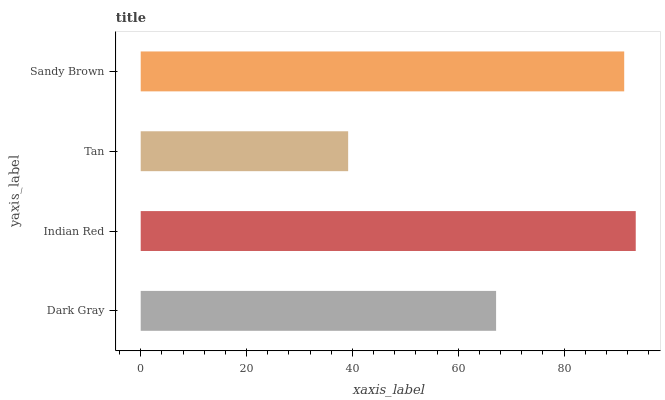Is Tan the minimum?
Answer yes or no. Yes. Is Indian Red the maximum?
Answer yes or no. Yes. Is Indian Red the minimum?
Answer yes or no. No. Is Tan the maximum?
Answer yes or no. No. Is Indian Red greater than Tan?
Answer yes or no. Yes. Is Tan less than Indian Red?
Answer yes or no. Yes. Is Tan greater than Indian Red?
Answer yes or no. No. Is Indian Red less than Tan?
Answer yes or no. No. Is Sandy Brown the high median?
Answer yes or no. Yes. Is Dark Gray the low median?
Answer yes or no. Yes. Is Tan the high median?
Answer yes or no. No. Is Indian Red the low median?
Answer yes or no. No. 